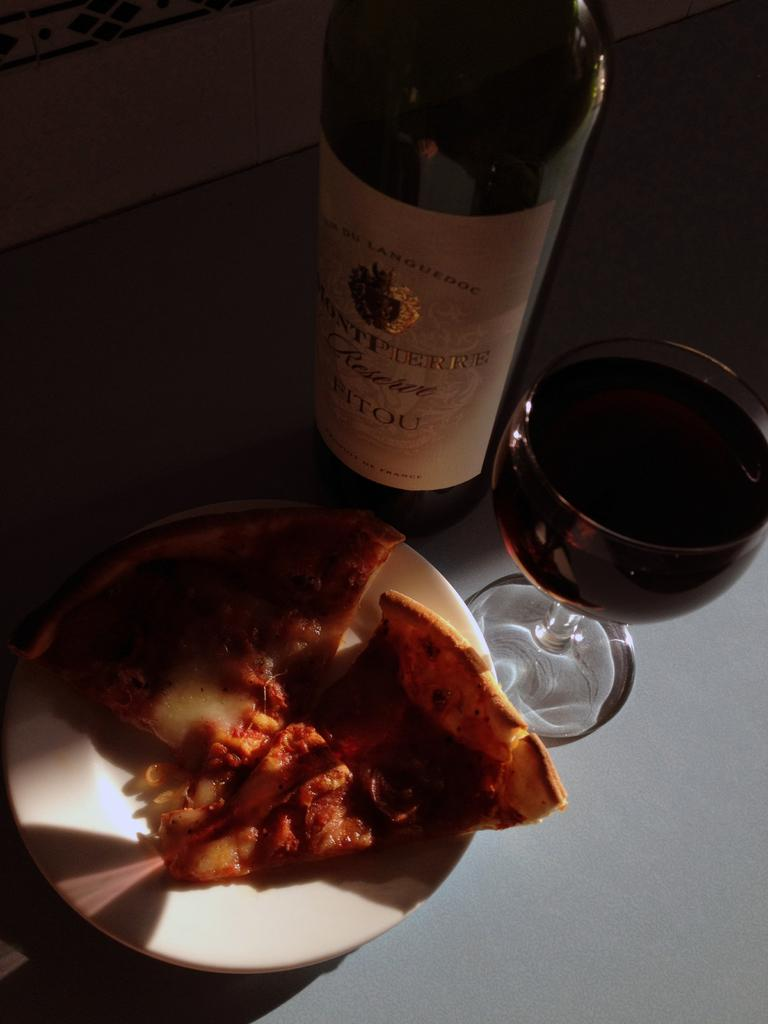<image>
Present a compact description of the photo's key features. A plate with slices of pizza, glass of wine placed next to a wine bottle with a label that says Fitou. 